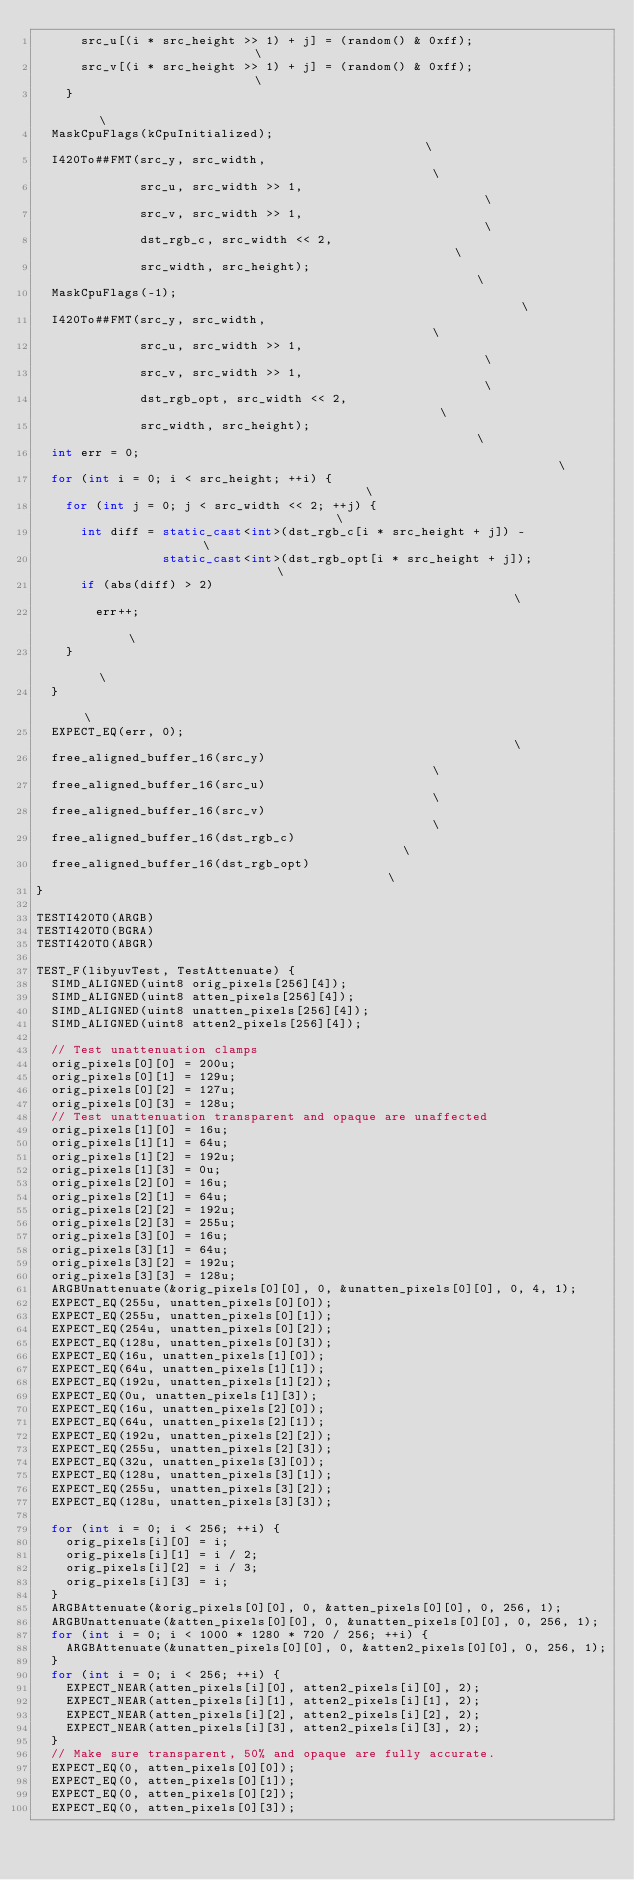Convert code to text. <code><loc_0><loc_0><loc_500><loc_500><_C++_>      src_u[(i * src_height >> 1) + j] = (random() & 0xff);                    \
      src_v[(i * src_height >> 1) + j] = (random() & 0xff);                    \
    }                                                                          \
  MaskCpuFlags(kCpuInitialized);                                               \
  I420To##FMT(src_y, src_width,                                                \
              src_u, src_width >> 1,                                           \
              src_v, src_width >> 1,                                           \
              dst_rgb_c, src_width << 2,                                       \
              src_width, src_height);                                          \
  MaskCpuFlags(-1);                                                            \
  I420To##FMT(src_y, src_width,                                                \
              src_u, src_width >> 1,                                           \
              src_v, src_width >> 1,                                           \
              dst_rgb_opt, src_width << 2,                                     \
              src_width, src_height);                                          \
  int err = 0;                                                                 \
  for (int i = 0; i < src_height; ++i) {                                       \
    for (int j = 0; j < src_width << 2; ++j) {                                 \
      int diff = static_cast<int>(dst_rgb_c[i * src_height + j]) -             \
                 static_cast<int>(dst_rgb_opt[i * src_height + j]);            \
      if (abs(diff) > 2)                                                       \
        err++;                                                                 \
    }                                                                          \
  }                                                                            \
  EXPECT_EQ(err, 0);                                                           \
  free_aligned_buffer_16(src_y)                                                \
  free_aligned_buffer_16(src_u)                                                \
  free_aligned_buffer_16(src_v)                                                \
  free_aligned_buffer_16(dst_rgb_c)                                            \
  free_aligned_buffer_16(dst_rgb_opt)                                          \
}

TESTI420TO(ARGB)
TESTI420TO(BGRA)
TESTI420TO(ABGR)

TEST_F(libyuvTest, TestAttenuate) {
  SIMD_ALIGNED(uint8 orig_pixels[256][4]);
  SIMD_ALIGNED(uint8 atten_pixels[256][4]);
  SIMD_ALIGNED(uint8 unatten_pixels[256][4]);
  SIMD_ALIGNED(uint8 atten2_pixels[256][4]);

  // Test unattenuation clamps
  orig_pixels[0][0] = 200u;
  orig_pixels[0][1] = 129u;
  orig_pixels[0][2] = 127u;
  orig_pixels[0][3] = 128u;
  // Test unattenuation transparent and opaque are unaffected
  orig_pixels[1][0] = 16u;
  orig_pixels[1][1] = 64u;
  orig_pixels[1][2] = 192u;
  orig_pixels[1][3] = 0u;
  orig_pixels[2][0] = 16u;
  orig_pixels[2][1] = 64u;
  orig_pixels[2][2] = 192u;
  orig_pixels[2][3] = 255u;
  orig_pixels[3][0] = 16u;
  orig_pixels[3][1] = 64u;
  orig_pixels[3][2] = 192u;
  orig_pixels[3][3] = 128u;
  ARGBUnattenuate(&orig_pixels[0][0], 0, &unatten_pixels[0][0], 0, 4, 1);
  EXPECT_EQ(255u, unatten_pixels[0][0]);
  EXPECT_EQ(255u, unatten_pixels[0][1]);
  EXPECT_EQ(254u, unatten_pixels[0][2]);
  EXPECT_EQ(128u, unatten_pixels[0][3]);
  EXPECT_EQ(16u, unatten_pixels[1][0]);
  EXPECT_EQ(64u, unatten_pixels[1][1]);
  EXPECT_EQ(192u, unatten_pixels[1][2]);
  EXPECT_EQ(0u, unatten_pixels[1][3]);
  EXPECT_EQ(16u, unatten_pixels[2][0]);
  EXPECT_EQ(64u, unatten_pixels[2][1]);
  EXPECT_EQ(192u, unatten_pixels[2][2]);
  EXPECT_EQ(255u, unatten_pixels[2][3]);
  EXPECT_EQ(32u, unatten_pixels[3][0]);
  EXPECT_EQ(128u, unatten_pixels[3][1]);
  EXPECT_EQ(255u, unatten_pixels[3][2]);
  EXPECT_EQ(128u, unatten_pixels[3][3]);

  for (int i = 0; i < 256; ++i) {
    orig_pixels[i][0] = i;
    orig_pixels[i][1] = i / 2;
    orig_pixels[i][2] = i / 3;
    orig_pixels[i][3] = i;
  }
  ARGBAttenuate(&orig_pixels[0][0], 0, &atten_pixels[0][0], 0, 256, 1);
  ARGBUnattenuate(&atten_pixels[0][0], 0, &unatten_pixels[0][0], 0, 256, 1);
  for (int i = 0; i < 1000 * 1280 * 720 / 256; ++i) {
    ARGBAttenuate(&unatten_pixels[0][0], 0, &atten2_pixels[0][0], 0, 256, 1);
  }
  for (int i = 0; i < 256; ++i) {
    EXPECT_NEAR(atten_pixels[i][0], atten2_pixels[i][0], 2);
    EXPECT_NEAR(atten_pixels[i][1], atten2_pixels[i][1], 2);
    EXPECT_NEAR(atten_pixels[i][2], atten2_pixels[i][2], 2);
    EXPECT_NEAR(atten_pixels[i][3], atten2_pixels[i][3], 2);
  }
  // Make sure transparent, 50% and opaque are fully accurate.
  EXPECT_EQ(0, atten_pixels[0][0]);
  EXPECT_EQ(0, atten_pixels[0][1]);
  EXPECT_EQ(0, atten_pixels[0][2]);
  EXPECT_EQ(0, atten_pixels[0][3]);</code> 